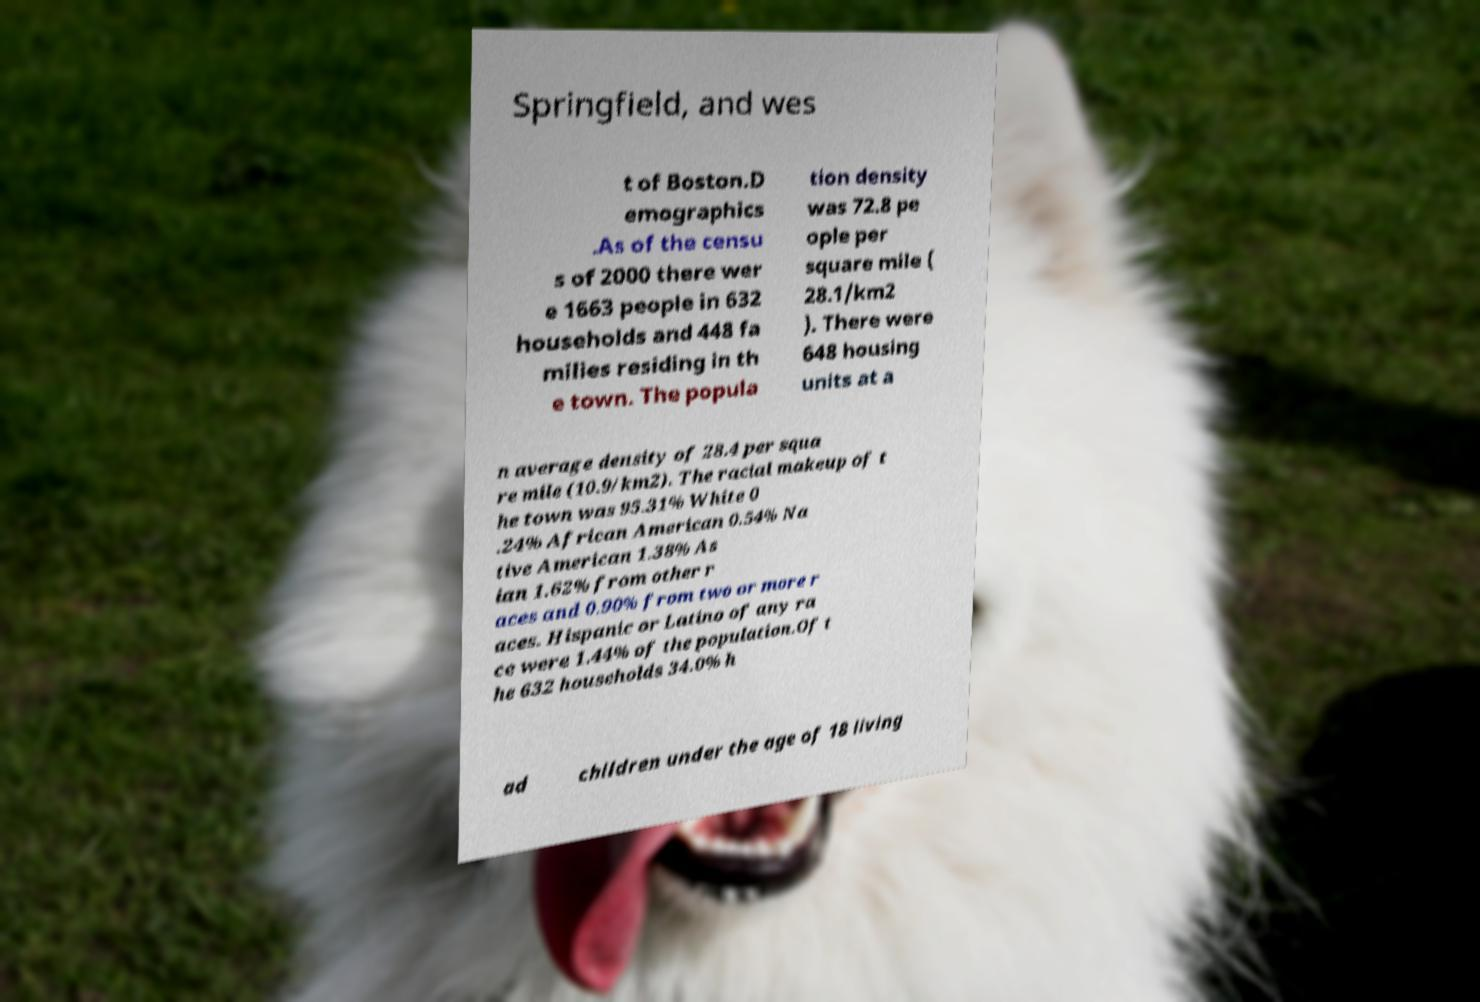Could you assist in decoding the text presented in this image and type it out clearly? Springfield, and wes t of Boston.D emographics .As of the censu s of 2000 there wer e 1663 people in 632 households and 448 fa milies residing in th e town. The popula tion density was 72.8 pe ople per square mile ( 28.1/km2 ). There were 648 housing units at a n average density of 28.4 per squa re mile (10.9/km2). The racial makeup of t he town was 95.31% White 0 .24% African American 0.54% Na tive American 1.38% As ian 1.62% from other r aces and 0.90% from two or more r aces. Hispanic or Latino of any ra ce were 1.44% of the population.Of t he 632 households 34.0% h ad children under the age of 18 living 